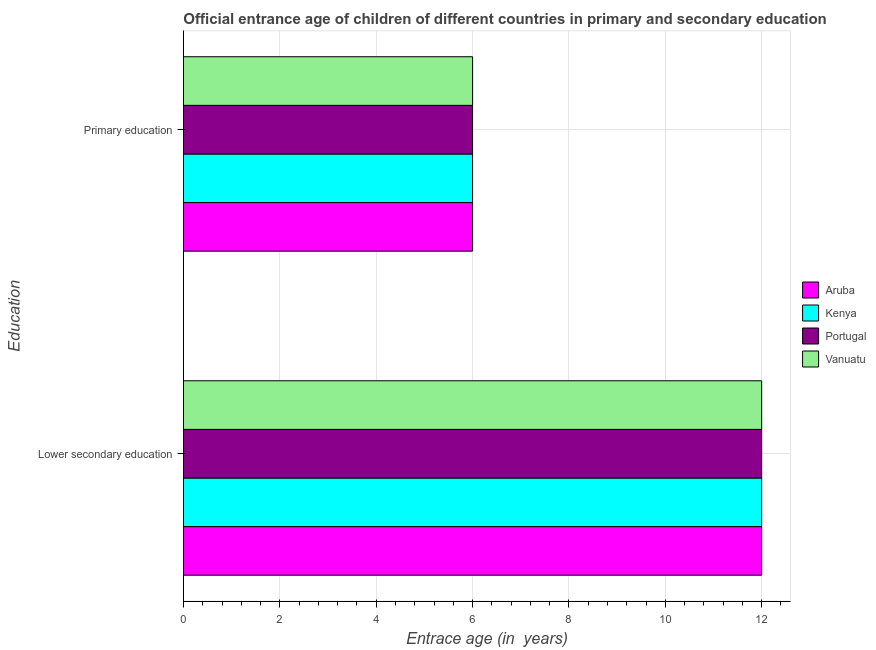How many different coloured bars are there?
Your response must be concise. 4. How many groups of bars are there?
Make the answer very short. 2. Are the number of bars per tick equal to the number of legend labels?
Your answer should be compact. Yes. How many bars are there on the 1st tick from the top?
Make the answer very short. 4. What is the label of the 2nd group of bars from the top?
Make the answer very short. Lower secondary education. Across all countries, what is the maximum entrance age of chiildren in primary education?
Give a very brief answer. 6. Across all countries, what is the minimum entrance age of children in lower secondary education?
Make the answer very short. 12. In which country was the entrance age of children in lower secondary education maximum?
Ensure brevity in your answer.  Aruba. In which country was the entrance age of chiildren in primary education minimum?
Keep it short and to the point. Aruba. What is the total entrance age of children in lower secondary education in the graph?
Provide a short and direct response. 48. What is the difference between the entrance age of children in lower secondary education in Kenya and the entrance age of chiildren in primary education in Portugal?
Provide a succinct answer. 6. What is the difference between the entrance age of children in lower secondary education and entrance age of chiildren in primary education in Portugal?
Offer a very short reply. 6. What is the ratio of the entrance age of chiildren in primary education in Portugal to that in Vanuatu?
Offer a terse response. 1. In how many countries, is the entrance age of chiildren in primary education greater than the average entrance age of chiildren in primary education taken over all countries?
Give a very brief answer. 0. What does the 4th bar from the top in Primary education represents?
Give a very brief answer. Aruba. What does the 1st bar from the bottom in Primary education represents?
Your answer should be very brief. Aruba. How many bars are there?
Your answer should be compact. 8. Does the graph contain any zero values?
Give a very brief answer. No. Does the graph contain grids?
Provide a succinct answer. Yes. Where does the legend appear in the graph?
Your answer should be compact. Center right. How many legend labels are there?
Your response must be concise. 4. How are the legend labels stacked?
Offer a very short reply. Vertical. What is the title of the graph?
Your answer should be compact. Official entrance age of children of different countries in primary and secondary education. What is the label or title of the X-axis?
Your answer should be very brief. Entrace age (in  years). What is the label or title of the Y-axis?
Your answer should be very brief. Education. What is the Entrace age (in  years) of Kenya in Lower secondary education?
Give a very brief answer. 12. What is the Entrace age (in  years) in Portugal in Lower secondary education?
Provide a short and direct response. 12. What is the Entrace age (in  years) of Vanuatu in Lower secondary education?
Ensure brevity in your answer.  12. What is the Entrace age (in  years) of Vanuatu in Primary education?
Make the answer very short. 6. Across all Education, what is the maximum Entrace age (in  years) in Vanuatu?
Your response must be concise. 12. Across all Education, what is the minimum Entrace age (in  years) in Aruba?
Offer a terse response. 6. Across all Education, what is the minimum Entrace age (in  years) in Vanuatu?
Ensure brevity in your answer.  6. What is the total Entrace age (in  years) in Aruba in the graph?
Your response must be concise. 18. What is the total Entrace age (in  years) of Kenya in the graph?
Make the answer very short. 18. What is the difference between the Entrace age (in  years) in Kenya in Lower secondary education and that in Primary education?
Provide a succinct answer. 6. What is the difference between the Entrace age (in  years) in Portugal in Lower secondary education and that in Primary education?
Make the answer very short. 6. What is the difference between the Entrace age (in  years) of Aruba in Lower secondary education and the Entrace age (in  years) of Kenya in Primary education?
Your answer should be very brief. 6. What is the difference between the Entrace age (in  years) in Aruba in Lower secondary education and the Entrace age (in  years) in Vanuatu in Primary education?
Keep it short and to the point. 6. What is the difference between the Entrace age (in  years) in Kenya in Lower secondary education and the Entrace age (in  years) in Portugal in Primary education?
Your answer should be compact. 6. What is the average Entrace age (in  years) in Aruba per Education?
Offer a very short reply. 9. What is the difference between the Entrace age (in  years) of Aruba and Entrace age (in  years) of Kenya in Lower secondary education?
Give a very brief answer. 0. What is the difference between the Entrace age (in  years) in Kenya and Entrace age (in  years) in Portugal in Lower secondary education?
Make the answer very short. 0. What is the difference between the Entrace age (in  years) of Kenya and Entrace age (in  years) of Vanuatu in Lower secondary education?
Your answer should be very brief. 0. What is the difference between the Entrace age (in  years) of Aruba and Entrace age (in  years) of Kenya in Primary education?
Ensure brevity in your answer.  0. What is the difference between the Entrace age (in  years) of Aruba and Entrace age (in  years) of Vanuatu in Primary education?
Ensure brevity in your answer.  0. What is the difference between the Entrace age (in  years) of Kenya and Entrace age (in  years) of Portugal in Primary education?
Keep it short and to the point. 0. What is the difference between the Entrace age (in  years) of Portugal and Entrace age (in  years) of Vanuatu in Primary education?
Make the answer very short. 0. What is the ratio of the Entrace age (in  years) of Aruba in Lower secondary education to that in Primary education?
Your answer should be very brief. 2. What is the difference between the highest and the second highest Entrace age (in  years) of Kenya?
Offer a terse response. 6. What is the difference between the highest and the second highest Entrace age (in  years) in Vanuatu?
Your response must be concise. 6. What is the difference between the highest and the lowest Entrace age (in  years) in Kenya?
Ensure brevity in your answer.  6. What is the difference between the highest and the lowest Entrace age (in  years) in Portugal?
Provide a succinct answer. 6. 